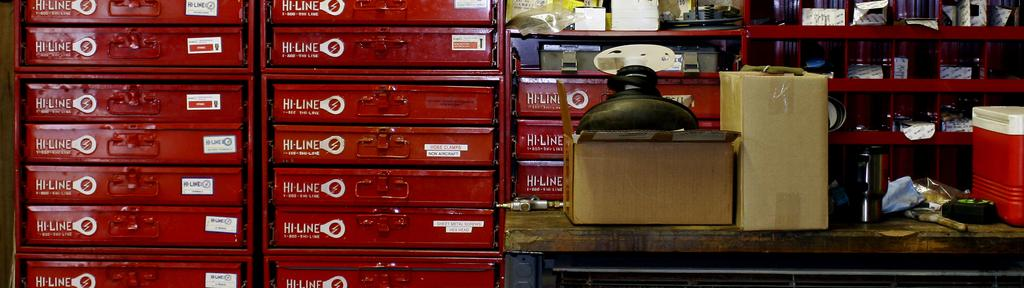<image>
Offer a succinct explanation of the picture presented. A portion of a workshop featuring a bright red Hi-Line tool chest. 